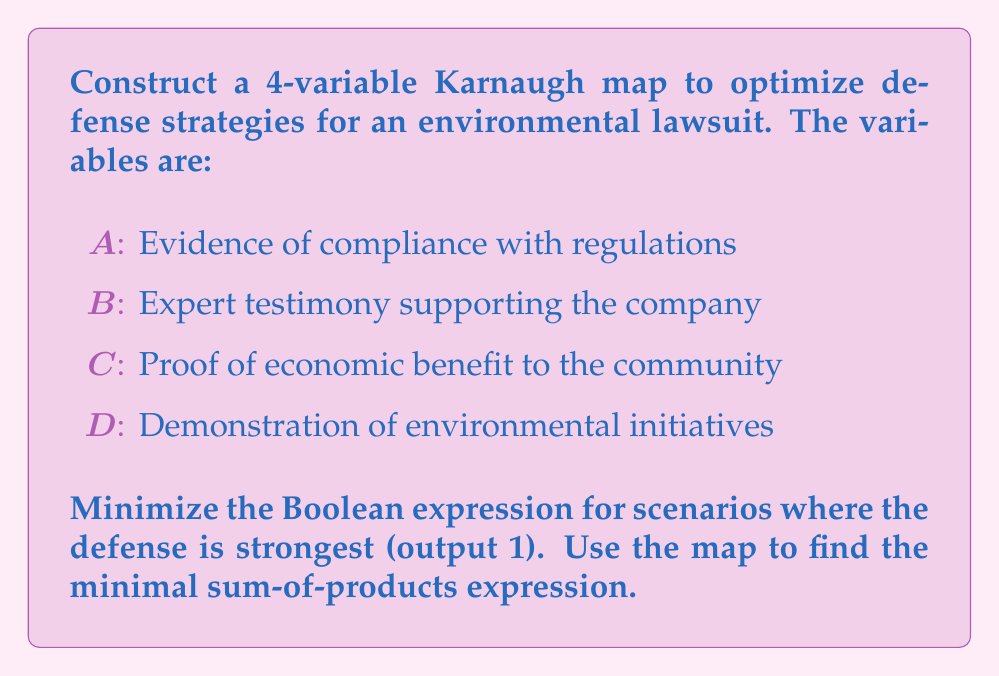Show me your answer to this math problem. 1. First, we need to create a 4-variable Karnaugh map. The map will have 16 cells (2^4).

2. We'll assign 1 to cells where the defense is strongest. This occurs when:
   - There's evidence of compliance (A) AND expert testimony (B)
   - There's proof of economic benefit (C) AND demonstration of initiatives (D)
   - There's evidence of compliance (A) AND proof of economic benefit (C)

3. Let's fill in the Karnaugh map:

[asy]
unitsize(1cm);
draw((0,0)--(4,0)--(4,4)--(0,4)--cycle);
draw((0,1)--(4,1));
draw((0,2)--(4,2));
draw((0,3)--(4,3));
draw((1,0)--(1,4));
draw((2,0)--(2,4));
draw((3,0)--(3,4));
label("00", (0.5,3.5));
label("01", (1.5,3.5));
label("11", (2.5,3.5));
label("10", (3.5,3.5));
label("00", (-0.5,3.5));
label("01", (-0.5,2.5));
label("11", (-0.5,1.5));
label("10", (-0.5,0.5));
label("AB", (-0.5,4.5));
label("CD", (2,4.5));
label("1", (0.5,2.5));
label("1", (1.5,2.5));
label("1", (2.5,2.5));
label("1", (3.5,2.5));
label("1", (0.5,1.5));
label("1", (1.5,1.5));
label("1", (2.5,1.5));
label("1", (3.5,1.5));
label("1", (2.5,3.5));
label("1", (3.5,3.5));
[/asy]

4. Now, we identify the largest possible groupings of 1s:
   - A group of 8: $\overline{C}D$ (bottom half of the map)
   - A group of 4: $AB$ (right half of the top two rows)

5. The minimal sum-of-products expression is the OR of these groups:

   $F = \overline{C}D + AB$

This expression represents the optimized defense strategy.
Answer: $F = \overline{C}D + AB$ 